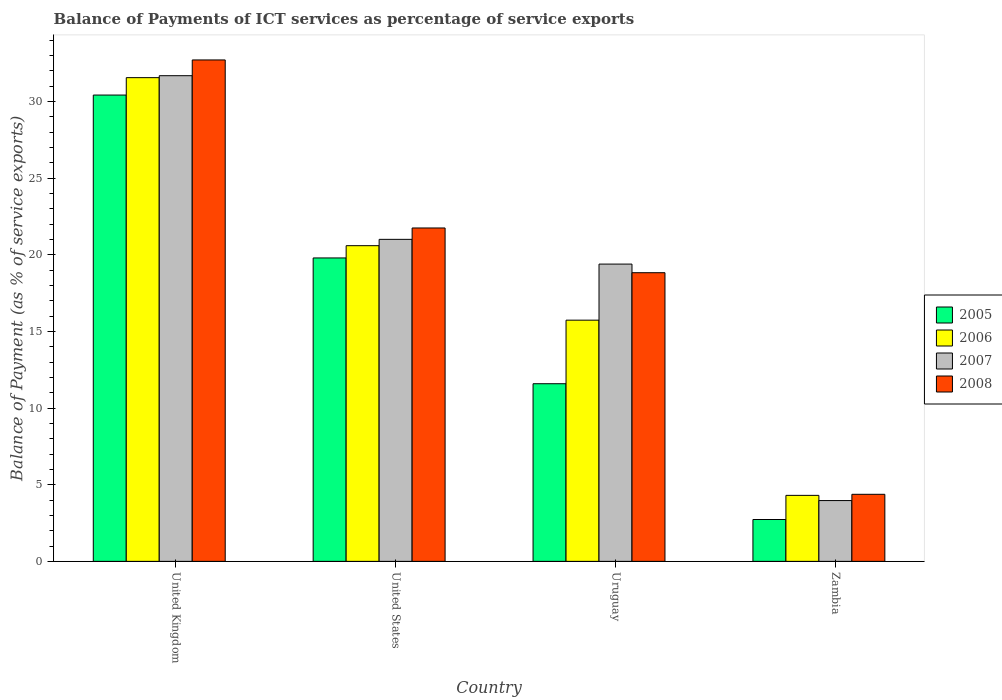How many different coloured bars are there?
Your answer should be very brief. 4. How many bars are there on the 3rd tick from the left?
Provide a succinct answer. 4. What is the balance of payments of ICT services in 2005 in United States?
Offer a very short reply. 19.79. Across all countries, what is the maximum balance of payments of ICT services in 2007?
Offer a very short reply. 31.68. Across all countries, what is the minimum balance of payments of ICT services in 2006?
Your answer should be compact. 4.3. In which country was the balance of payments of ICT services in 2005 minimum?
Your answer should be very brief. Zambia. What is the total balance of payments of ICT services in 2006 in the graph?
Ensure brevity in your answer.  72.17. What is the difference between the balance of payments of ICT services in 2006 in United Kingdom and that in United States?
Offer a very short reply. 10.96. What is the difference between the balance of payments of ICT services in 2007 in Uruguay and the balance of payments of ICT services in 2006 in Zambia?
Provide a succinct answer. 15.09. What is the average balance of payments of ICT services in 2006 per country?
Make the answer very short. 18.04. What is the difference between the balance of payments of ICT services of/in 2008 and balance of payments of ICT services of/in 2007 in Zambia?
Offer a very short reply. 0.41. In how many countries, is the balance of payments of ICT services in 2006 greater than 6 %?
Your answer should be compact. 3. What is the ratio of the balance of payments of ICT services in 2008 in United Kingdom to that in Zambia?
Offer a terse response. 7.48. What is the difference between the highest and the second highest balance of payments of ICT services in 2005?
Your answer should be very brief. -8.2. What is the difference between the highest and the lowest balance of payments of ICT services in 2006?
Your answer should be very brief. 27.24. In how many countries, is the balance of payments of ICT services in 2007 greater than the average balance of payments of ICT services in 2007 taken over all countries?
Ensure brevity in your answer.  3. Is it the case that in every country, the sum of the balance of payments of ICT services in 2006 and balance of payments of ICT services in 2005 is greater than the sum of balance of payments of ICT services in 2007 and balance of payments of ICT services in 2008?
Offer a very short reply. No. Are all the bars in the graph horizontal?
Offer a very short reply. No. How many countries are there in the graph?
Your answer should be compact. 4. Are the values on the major ticks of Y-axis written in scientific E-notation?
Provide a short and direct response. No. Does the graph contain any zero values?
Provide a short and direct response. No. How many legend labels are there?
Keep it short and to the point. 4. How are the legend labels stacked?
Your response must be concise. Vertical. What is the title of the graph?
Give a very brief answer. Balance of Payments of ICT services as percentage of service exports. Does "1993" appear as one of the legend labels in the graph?
Offer a terse response. No. What is the label or title of the Y-axis?
Offer a very short reply. Balance of Payment (as % of service exports). What is the Balance of Payment (as % of service exports) in 2005 in United Kingdom?
Keep it short and to the point. 30.41. What is the Balance of Payment (as % of service exports) in 2006 in United Kingdom?
Ensure brevity in your answer.  31.55. What is the Balance of Payment (as % of service exports) of 2007 in United Kingdom?
Your answer should be compact. 31.68. What is the Balance of Payment (as % of service exports) of 2008 in United Kingdom?
Make the answer very short. 32.7. What is the Balance of Payment (as % of service exports) in 2005 in United States?
Give a very brief answer. 19.79. What is the Balance of Payment (as % of service exports) of 2006 in United States?
Keep it short and to the point. 20.59. What is the Balance of Payment (as % of service exports) in 2007 in United States?
Offer a terse response. 21. What is the Balance of Payment (as % of service exports) in 2008 in United States?
Keep it short and to the point. 21.74. What is the Balance of Payment (as % of service exports) of 2005 in Uruguay?
Provide a succinct answer. 11.59. What is the Balance of Payment (as % of service exports) of 2006 in Uruguay?
Provide a short and direct response. 15.73. What is the Balance of Payment (as % of service exports) of 2007 in Uruguay?
Provide a short and direct response. 19.39. What is the Balance of Payment (as % of service exports) in 2008 in Uruguay?
Your answer should be compact. 18.83. What is the Balance of Payment (as % of service exports) of 2005 in Zambia?
Your response must be concise. 2.73. What is the Balance of Payment (as % of service exports) in 2006 in Zambia?
Make the answer very short. 4.3. What is the Balance of Payment (as % of service exports) in 2007 in Zambia?
Your answer should be compact. 3.96. What is the Balance of Payment (as % of service exports) of 2008 in Zambia?
Provide a succinct answer. 4.37. Across all countries, what is the maximum Balance of Payment (as % of service exports) of 2005?
Offer a terse response. 30.41. Across all countries, what is the maximum Balance of Payment (as % of service exports) in 2006?
Ensure brevity in your answer.  31.55. Across all countries, what is the maximum Balance of Payment (as % of service exports) in 2007?
Offer a very short reply. 31.68. Across all countries, what is the maximum Balance of Payment (as % of service exports) in 2008?
Provide a short and direct response. 32.7. Across all countries, what is the minimum Balance of Payment (as % of service exports) in 2005?
Offer a very short reply. 2.73. Across all countries, what is the minimum Balance of Payment (as % of service exports) in 2006?
Your answer should be very brief. 4.3. Across all countries, what is the minimum Balance of Payment (as % of service exports) of 2007?
Offer a terse response. 3.96. Across all countries, what is the minimum Balance of Payment (as % of service exports) of 2008?
Keep it short and to the point. 4.37. What is the total Balance of Payment (as % of service exports) of 2005 in the graph?
Keep it short and to the point. 64.52. What is the total Balance of Payment (as % of service exports) of 2006 in the graph?
Make the answer very short. 72.17. What is the total Balance of Payment (as % of service exports) in 2007 in the graph?
Offer a terse response. 76.03. What is the total Balance of Payment (as % of service exports) in 2008 in the graph?
Provide a short and direct response. 77.65. What is the difference between the Balance of Payment (as % of service exports) in 2005 in United Kingdom and that in United States?
Make the answer very short. 10.62. What is the difference between the Balance of Payment (as % of service exports) of 2006 in United Kingdom and that in United States?
Offer a very short reply. 10.96. What is the difference between the Balance of Payment (as % of service exports) in 2007 in United Kingdom and that in United States?
Your answer should be very brief. 10.67. What is the difference between the Balance of Payment (as % of service exports) in 2008 in United Kingdom and that in United States?
Ensure brevity in your answer.  10.96. What is the difference between the Balance of Payment (as % of service exports) in 2005 in United Kingdom and that in Uruguay?
Your answer should be compact. 18.83. What is the difference between the Balance of Payment (as % of service exports) in 2006 in United Kingdom and that in Uruguay?
Offer a very short reply. 15.82. What is the difference between the Balance of Payment (as % of service exports) in 2007 in United Kingdom and that in Uruguay?
Give a very brief answer. 12.29. What is the difference between the Balance of Payment (as % of service exports) of 2008 in United Kingdom and that in Uruguay?
Ensure brevity in your answer.  13.88. What is the difference between the Balance of Payment (as % of service exports) in 2005 in United Kingdom and that in Zambia?
Offer a very short reply. 27.68. What is the difference between the Balance of Payment (as % of service exports) in 2006 in United Kingdom and that in Zambia?
Make the answer very short. 27.24. What is the difference between the Balance of Payment (as % of service exports) of 2007 in United Kingdom and that in Zambia?
Your response must be concise. 27.71. What is the difference between the Balance of Payment (as % of service exports) of 2008 in United Kingdom and that in Zambia?
Make the answer very short. 28.33. What is the difference between the Balance of Payment (as % of service exports) of 2005 in United States and that in Uruguay?
Offer a very short reply. 8.2. What is the difference between the Balance of Payment (as % of service exports) in 2006 in United States and that in Uruguay?
Provide a succinct answer. 4.86. What is the difference between the Balance of Payment (as % of service exports) of 2007 in United States and that in Uruguay?
Your answer should be very brief. 1.61. What is the difference between the Balance of Payment (as % of service exports) of 2008 in United States and that in Uruguay?
Your answer should be very brief. 2.92. What is the difference between the Balance of Payment (as % of service exports) in 2005 in United States and that in Zambia?
Your answer should be compact. 17.06. What is the difference between the Balance of Payment (as % of service exports) in 2006 in United States and that in Zambia?
Keep it short and to the point. 16.29. What is the difference between the Balance of Payment (as % of service exports) in 2007 in United States and that in Zambia?
Your answer should be very brief. 17.04. What is the difference between the Balance of Payment (as % of service exports) in 2008 in United States and that in Zambia?
Your answer should be compact. 17.37. What is the difference between the Balance of Payment (as % of service exports) of 2005 in Uruguay and that in Zambia?
Provide a succinct answer. 8.86. What is the difference between the Balance of Payment (as % of service exports) in 2006 in Uruguay and that in Zambia?
Make the answer very short. 11.43. What is the difference between the Balance of Payment (as % of service exports) in 2007 in Uruguay and that in Zambia?
Your response must be concise. 15.42. What is the difference between the Balance of Payment (as % of service exports) of 2008 in Uruguay and that in Zambia?
Keep it short and to the point. 14.45. What is the difference between the Balance of Payment (as % of service exports) in 2005 in United Kingdom and the Balance of Payment (as % of service exports) in 2006 in United States?
Your response must be concise. 9.82. What is the difference between the Balance of Payment (as % of service exports) in 2005 in United Kingdom and the Balance of Payment (as % of service exports) in 2007 in United States?
Keep it short and to the point. 9.41. What is the difference between the Balance of Payment (as % of service exports) of 2005 in United Kingdom and the Balance of Payment (as % of service exports) of 2008 in United States?
Provide a succinct answer. 8.67. What is the difference between the Balance of Payment (as % of service exports) in 2006 in United Kingdom and the Balance of Payment (as % of service exports) in 2007 in United States?
Keep it short and to the point. 10.55. What is the difference between the Balance of Payment (as % of service exports) in 2006 in United Kingdom and the Balance of Payment (as % of service exports) in 2008 in United States?
Offer a terse response. 9.8. What is the difference between the Balance of Payment (as % of service exports) of 2007 in United Kingdom and the Balance of Payment (as % of service exports) of 2008 in United States?
Offer a very short reply. 9.93. What is the difference between the Balance of Payment (as % of service exports) in 2005 in United Kingdom and the Balance of Payment (as % of service exports) in 2006 in Uruguay?
Make the answer very short. 14.68. What is the difference between the Balance of Payment (as % of service exports) in 2005 in United Kingdom and the Balance of Payment (as % of service exports) in 2007 in Uruguay?
Your answer should be compact. 11.02. What is the difference between the Balance of Payment (as % of service exports) of 2005 in United Kingdom and the Balance of Payment (as % of service exports) of 2008 in Uruguay?
Give a very brief answer. 11.59. What is the difference between the Balance of Payment (as % of service exports) in 2006 in United Kingdom and the Balance of Payment (as % of service exports) in 2007 in Uruguay?
Make the answer very short. 12.16. What is the difference between the Balance of Payment (as % of service exports) of 2006 in United Kingdom and the Balance of Payment (as % of service exports) of 2008 in Uruguay?
Give a very brief answer. 12.72. What is the difference between the Balance of Payment (as % of service exports) of 2007 in United Kingdom and the Balance of Payment (as % of service exports) of 2008 in Uruguay?
Offer a very short reply. 12.85. What is the difference between the Balance of Payment (as % of service exports) in 2005 in United Kingdom and the Balance of Payment (as % of service exports) in 2006 in Zambia?
Offer a terse response. 26.11. What is the difference between the Balance of Payment (as % of service exports) in 2005 in United Kingdom and the Balance of Payment (as % of service exports) in 2007 in Zambia?
Ensure brevity in your answer.  26.45. What is the difference between the Balance of Payment (as % of service exports) in 2005 in United Kingdom and the Balance of Payment (as % of service exports) in 2008 in Zambia?
Provide a succinct answer. 26.04. What is the difference between the Balance of Payment (as % of service exports) in 2006 in United Kingdom and the Balance of Payment (as % of service exports) in 2007 in Zambia?
Offer a terse response. 27.58. What is the difference between the Balance of Payment (as % of service exports) in 2006 in United Kingdom and the Balance of Payment (as % of service exports) in 2008 in Zambia?
Offer a very short reply. 27.17. What is the difference between the Balance of Payment (as % of service exports) in 2007 in United Kingdom and the Balance of Payment (as % of service exports) in 2008 in Zambia?
Your answer should be compact. 27.3. What is the difference between the Balance of Payment (as % of service exports) of 2005 in United States and the Balance of Payment (as % of service exports) of 2006 in Uruguay?
Ensure brevity in your answer.  4.06. What is the difference between the Balance of Payment (as % of service exports) of 2005 in United States and the Balance of Payment (as % of service exports) of 2007 in Uruguay?
Provide a short and direct response. 0.4. What is the difference between the Balance of Payment (as % of service exports) in 2005 in United States and the Balance of Payment (as % of service exports) in 2008 in Uruguay?
Your answer should be very brief. 0.96. What is the difference between the Balance of Payment (as % of service exports) in 2006 in United States and the Balance of Payment (as % of service exports) in 2007 in Uruguay?
Offer a terse response. 1.2. What is the difference between the Balance of Payment (as % of service exports) of 2006 in United States and the Balance of Payment (as % of service exports) of 2008 in Uruguay?
Your answer should be compact. 1.76. What is the difference between the Balance of Payment (as % of service exports) of 2007 in United States and the Balance of Payment (as % of service exports) of 2008 in Uruguay?
Ensure brevity in your answer.  2.18. What is the difference between the Balance of Payment (as % of service exports) of 2005 in United States and the Balance of Payment (as % of service exports) of 2006 in Zambia?
Provide a short and direct response. 15.49. What is the difference between the Balance of Payment (as % of service exports) of 2005 in United States and the Balance of Payment (as % of service exports) of 2007 in Zambia?
Keep it short and to the point. 15.82. What is the difference between the Balance of Payment (as % of service exports) of 2005 in United States and the Balance of Payment (as % of service exports) of 2008 in Zambia?
Offer a very short reply. 15.42. What is the difference between the Balance of Payment (as % of service exports) of 2006 in United States and the Balance of Payment (as % of service exports) of 2007 in Zambia?
Provide a succinct answer. 16.62. What is the difference between the Balance of Payment (as % of service exports) in 2006 in United States and the Balance of Payment (as % of service exports) in 2008 in Zambia?
Your response must be concise. 16.22. What is the difference between the Balance of Payment (as % of service exports) of 2007 in United States and the Balance of Payment (as % of service exports) of 2008 in Zambia?
Give a very brief answer. 16.63. What is the difference between the Balance of Payment (as % of service exports) in 2005 in Uruguay and the Balance of Payment (as % of service exports) in 2006 in Zambia?
Provide a short and direct response. 7.28. What is the difference between the Balance of Payment (as % of service exports) of 2005 in Uruguay and the Balance of Payment (as % of service exports) of 2007 in Zambia?
Keep it short and to the point. 7.62. What is the difference between the Balance of Payment (as % of service exports) of 2005 in Uruguay and the Balance of Payment (as % of service exports) of 2008 in Zambia?
Offer a very short reply. 7.21. What is the difference between the Balance of Payment (as % of service exports) in 2006 in Uruguay and the Balance of Payment (as % of service exports) in 2007 in Zambia?
Ensure brevity in your answer.  11.77. What is the difference between the Balance of Payment (as % of service exports) in 2006 in Uruguay and the Balance of Payment (as % of service exports) in 2008 in Zambia?
Provide a short and direct response. 11.36. What is the difference between the Balance of Payment (as % of service exports) in 2007 in Uruguay and the Balance of Payment (as % of service exports) in 2008 in Zambia?
Your answer should be compact. 15.02. What is the average Balance of Payment (as % of service exports) in 2005 per country?
Give a very brief answer. 16.13. What is the average Balance of Payment (as % of service exports) of 2006 per country?
Your response must be concise. 18.04. What is the average Balance of Payment (as % of service exports) in 2007 per country?
Your answer should be very brief. 19.01. What is the average Balance of Payment (as % of service exports) in 2008 per country?
Your answer should be compact. 19.41. What is the difference between the Balance of Payment (as % of service exports) of 2005 and Balance of Payment (as % of service exports) of 2006 in United Kingdom?
Keep it short and to the point. -1.14. What is the difference between the Balance of Payment (as % of service exports) in 2005 and Balance of Payment (as % of service exports) in 2007 in United Kingdom?
Give a very brief answer. -1.26. What is the difference between the Balance of Payment (as % of service exports) in 2005 and Balance of Payment (as % of service exports) in 2008 in United Kingdom?
Your answer should be compact. -2.29. What is the difference between the Balance of Payment (as % of service exports) of 2006 and Balance of Payment (as % of service exports) of 2007 in United Kingdom?
Your answer should be compact. -0.13. What is the difference between the Balance of Payment (as % of service exports) in 2006 and Balance of Payment (as % of service exports) in 2008 in United Kingdom?
Provide a succinct answer. -1.16. What is the difference between the Balance of Payment (as % of service exports) in 2007 and Balance of Payment (as % of service exports) in 2008 in United Kingdom?
Your answer should be compact. -1.03. What is the difference between the Balance of Payment (as % of service exports) of 2005 and Balance of Payment (as % of service exports) of 2006 in United States?
Ensure brevity in your answer.  -0.8. What is the difference between the Balance of Payment (as % of service exports) of 2005 and Balance of Payment (as % of service exports) of 2007 in United States?
Your response must be concise. -1.21. What is the difference between the Balance of Payment (as % of service exports) in 2005 and Balance of Payment (as % of service exports) in 2008 in United States?
Your response must be concise. -1.95. What is the difference between the Balance of Payment (as % of service exports) in 2006 and Balance of Payment (as % of service exports) in 2007 in United States?
Give a very brief answer. -0.41. What is the difference between the Balance of Payment (as % of service exports) of 2006 and Balance of Payment (as % of service exports) of 2008 in United States?
Give a very brief answer. -1.15. What is the difference between the Balance of Payment (as % of service exports) in 2007 and Balance of Payment (as % of service exports) in 2008 in United States?
Give a very brief answer. -0.74. What is the difference between the Balance of Payment (as % of service exports) of 2005 and Balance of Payment (as % of service exports) of 2006 in Uruguay?
Provide a short and direct response. -4.15. What is the difference between the Balance of Payment (as % of service exports) of 2005 and Balance of Payment (as % of service exports) of 2007 in Uruguay?
Make the answer very short. -7.8. What is the difference between the Balance of Payment (as % of service exports) of 2005 and Balance of Payment (as % of service exports) of 2008 in Uruguay?
Provide a succinct answer. -7.24. What is the difference between the Balance of Payment (as % of service exports) in 2006 and Balance of Payment (as % of service exports) in 2007 in Uruguay?
Your answer should be very brief. -3.66. What is the difference between the Balance of Payment (as % of service exports) of 2006 and Balance of Payment (as % of service exports) of 2008 in Uruguay?
Ensure brevity in your answer.  -3.09. What is the difference between the Balance of Payment (as % of service exports) of 2007 and Balance of Payment (as % of service exports) of 2008 in Uruguay?
Your answer should be compact. 0.56. What is the difference between the Balance of Payment (as % of service exports) of 2005 and Balance of Payment (as % of service exports) of 2006 in Zambia?
Keep it short and to the point. -1.57. What is the difference between the Balance of Payment (as % of service exports) in 2005 and Balance of Payment (as % of service exports) in 2007 in Zambia?
Give a very brief answer. -1.23. What is the difference between the Balance of Payment (as % of service exports) of 2005 and Balance of Payment (as % of service exports) of 2008 in Zambia?
Keep it short and to the point. -1.64. What is the difference between the Balance of Payment (as % of service exports) of 2006 and Balance of Payment (as % of service exports) of 2007 in Zambia?
Provide a succinct answer. 0.34. What is the difference between the Balance of Payment (as % of service exports) of 2006 and Balance of Payment (as % of service exports) of 2008 in Zambia?
Give a very brief answer. -0.07. What is the difference between the Balance of Payment (as % of service exports) in 2007 and Balance of Payment (as % of service exports) in 2008 in Zambia?
Your answer should be compact. -0.41. What is the ratio of the Balance of Payment (as % of service exports) of 2005 in United Kingdom to that in United States?
Your response must be concise. 1.54. What is the ratio of the Balance of Payment (as % of service exports) of 2006 in United Kingdom to that in United States?
Make the answer very short. 1.53. What is the ratio of the Balance of Payment (as % of service exports) in 2007 in United Kingdom to that in United States?
Keep it short and to the point. 1.51. What is the ratio of the Balance of Payment (as % of service exports) in 2008 in United Kingdom to that in United States?
Your response must be concise. 1.5. What is the ratio of the Balance of Payment (as % of service exports) in 2005 in United Kingdom to that in Uruguay?
Your answer should be compact. 2.62. What is the ratio of the Balance of Payment (as % of service exports) in 2006 in United Kingdom to that in Uruguay?
Your answer should be very brief. 2.01. What is the ratio of the Balance of Payment (as % of service exports) of 2007 in United Kingdom to that in Uruguay?
Make the answer very short. 1.63. What is the ratio of the Balance of Payment (as % of service exports) of 2008 in United Kingdom to that in Uruguay?
Ensure brevity in your answer.  1.74. What is the ratio of the Balance of Payment (as % of service exports) in 2005 in United Kingdom to that in Zambia?
Keep it short and to the point. 11.14. What is the ratio of the Balance of Payment (as % of service exports) of 2006 in United Kingdom to that in Zambia?
Provide a short and direct response. 7.33. What is the ratio of the Balance of Payment (as % of service exports) in 2007 in United Kingdom to that in Zambia?
Provide a succinct answer. 7.99. What is the ratio of the Balance of Payment (as % of service exports) of 2008 in United Kingdom to that in Zambia?
Your response must be concise. 7.48. What is the ratio of the Balance of Payment (as % of service exports) in 2005 in United States to that in Uruguay?
Give a very brief answer. 1.71. What is the ratio of the Balance of Payment (as % of service exports) in 2006 in United States to that in Uruguay?
Your answer should be compact. 1.31. What is the ratio of the Balance of Payment (as % of service exports) of 2007 in United States to that in Uruguay?
Offer a terse response. 1.08. What is the ratio of the Balance of Payment (as % of service exports) in 2008 in United States to that in Uruguay?
Offer a very short reply. 1.16. What is the ratio of the Balance of Payment (as % of service exports) in 2005 in United States to that in Zambia?
Keep it short and to the point. 7.25. What is the ratio of the Balance of Payment (as % of service exports) of 2006 in United States to that in Zambia?
Keep it short and to the point. 4.78. What is the ratio of the Balance of Payment (as % of service exports) in 2007 in United States to that in Zambia?
Your answer should be very brief. 5.3. What is the ratio of the Balance of Payment (as % of service exports) of 2008 in United States to that in Zambia?
Provide a short and direct response. 4.97. What is the ratio of the Balance of Payment (as % of service exports) of 2005 in Uruguay to that in Zambia?
Offer a very short reply. 4.24. What is the ratio of the Balance of Payment (as % of service exports) in 2006 in Uruguay to that in Zambia?
Offer a very short reply. 3.66. What is the ratio of the Balance of Payment (as % of service exports) of 2007 in Uruguay to that in Zambia?
Keep it short and to the point. 4.89. What is the ratio of the Balance of Payment (as % of service exports) of 2008 in Uruguay to that in Zambia?
Provide a succinct answer. 4.3. What is the difference between the highest and the second highest Balance of Payment (as % of service exports) in 2005?
Your answer should be compact. 10.62. What is the difference between the highest and the second highest Balance of Payment (as % of service exports) in 2006?
Your answer should be very brief. 10.96. What is the difference between the highest and the second highest Balance of Payment (as % of service exports) in 2007?
Provide a short and direct response. 10.67. What is the difference between the highest and the second highest Balance of Payment (as % of service exports) of 2008?
Give a very brief answer. 10.96. What is the difference between the highest and the lowest Balance of Payment (as % of service exports) in 2005?
Ensure brevity in your answer.  27.68. What is the difference between the highest and the lowest Balance of Payment (as % of service exports) of 2006?
Your answer should be very brief. 27.24. What is the difference between the highest and the lowest Balance of Payment (as % of service exports) of 2007?
Provide a succinct answer. 27.71. What is the difference between the highest and the lowest Balance of Payment (as % of service exports) in 2008?
Offer a very short reply. 28.33. 